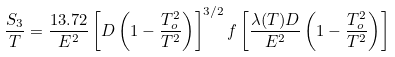<formula> <loc_0><loc_0><loc_500><loc_500>\frac { S _ { 3 } } { T } = \frac { 1 3 . 7 2 } { E ^ { 2 } } \left [ D \left ( 1 - \frac { T _ { o } ^ { 2 } } { T ^ { 2 } } \right ) \right ] ^ { 3 / 2 } f \left [ \frac { \lambda ( T ) D } { E ^ { 2 } } \left ( 1 - \frac { T _ { o } ^ { 2 } } { T ^ { 2 } } \right ) \right ]</formula> 